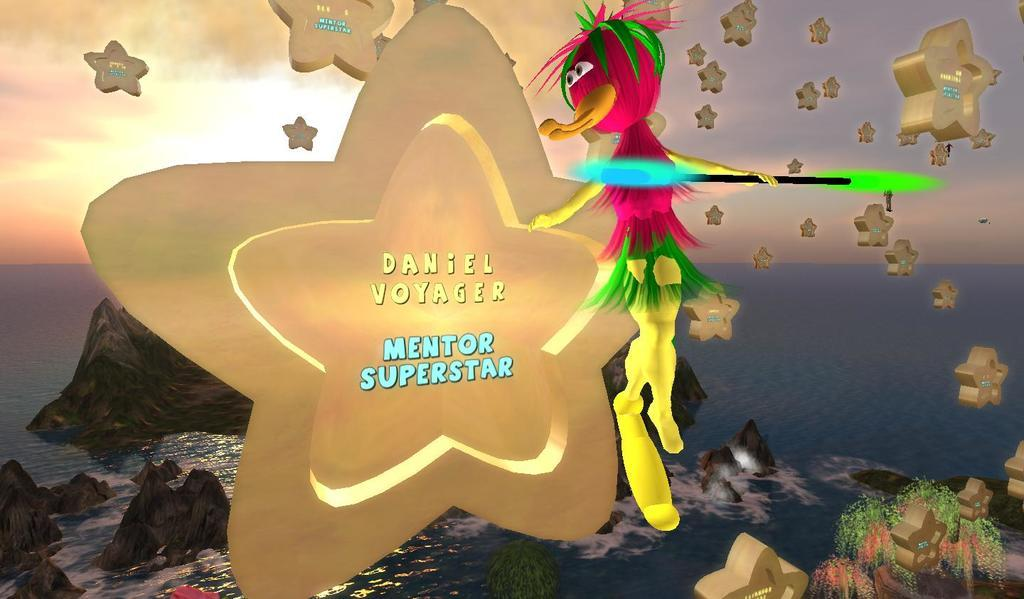What type of image is being described? The image is animated. What can be seen in the water in the image? There are rocks visible in the water. What celestial objects are present in the image? Stars are visible in the image. What type of object is present in the image? There is a toy in the image. What type of vegetation is present in the image? Plants are present in the image. What part of the natural environment is visible in the image? The sky is visible in the image. What type of winter clothing is being worn by the plants in the image? There are no plants wearing winter clothing in the image, as plants do not wear clothing. 